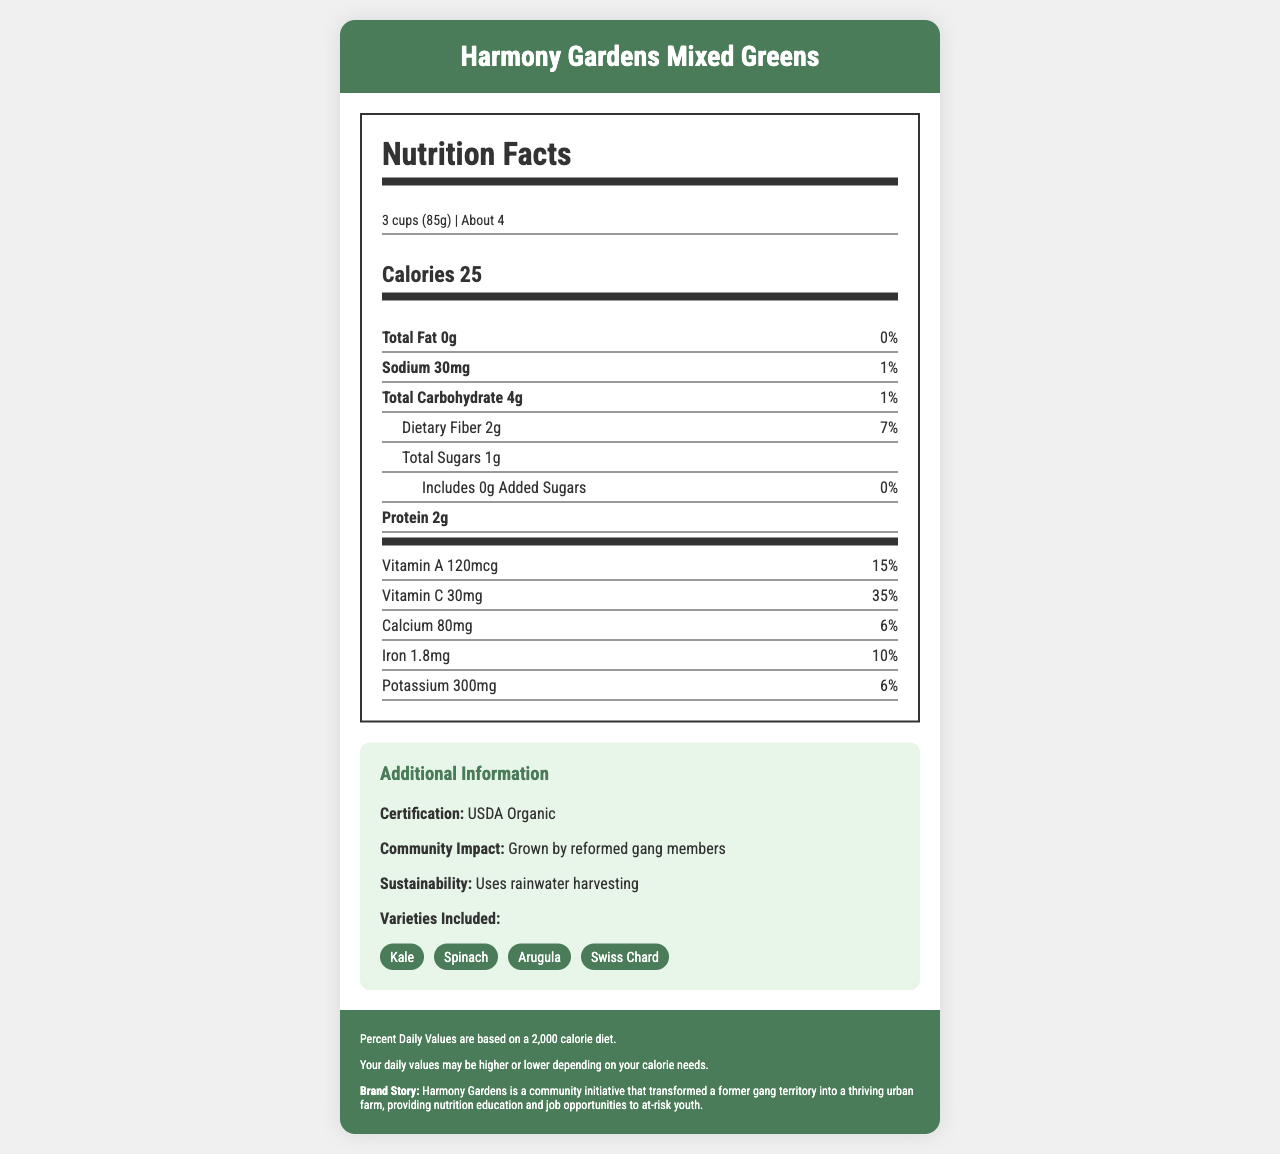What is the serving size for Harmony Gardens Mixed Greens? The serving size is mentioned at the top of the nutrition facts label and reads "3 cups (85g)".
Answer: 3 cups (85g) How many servings are there per container? This information is located next to the serving size information at the top of the nutrition facts label.
Answer: About 4 How many calories are in each serving? The number of calories per serving is prominently displayed under the serving size and servings per container information.
Answer: 25 calories What percentage of the daily value is the dietary fiber? The percentage daily value for dietary fiber is listed next to the amount of dietary fiber (2g).
Answer: 7% What are the main varieties included in Harmony Gardens Mixed Greens? The varieties included are listed in the additional information section under "Varieties Included".
Answer: Kale, Spinach, Arugula, Swiss Chard What is the total amount of fat per serving? A. 0g B. 2g C. 4g D. 25g The total amount of fat per serving is stated as "0g" under the nutrient information section.
Answer: A. 0g Which nutrient provides the highest percent daily value per serving? A. Vitamin A B. Protein C. Sodium D. Vitamin C Vitamin C has the highest percent daily value per serving at 35%, which is higher than the other listed nutrients.
Answer: D. Vitamin C Is Harmony Gardens Mixed Greens certified organic? The document states in the additional information section that it is "USDA Organic" certified.
Answer: Yes Does Harmony Gardens Mixed Greens have any added sugars? The document explicitly states that there are "0g" of added sugars under the nutrient information section.
Answer: No Summarize the main ideas presented in the Harmony Gardens Mixed Greens nutrition facts document. The document provides nutritional information, serving details, and additional insights into the community and sustainability efforts behind the product.
Answer: Harmony Gardens Mixed Greens is a USDA Organic certified product grown by reformed gang members. It offers nutritional benefits with low calories and fat, and significant amounts of vitamins and minerals. The mixed greens include varieties like kale, spinach, arugula, and Swiss chard. The product supports sustainability through rainwater harvesting and has a significant community impact. Does the document specify the exact calorie needs for each individual? The document includes disclaimers stating that percent daily values are based on a 2,000-calorie diet and that individual daily values may vary.
Answer: No Where is Harmony Gardens located? The document does not provide any specific information about the location of Harmony Gardens.
Answer: Not enough information 